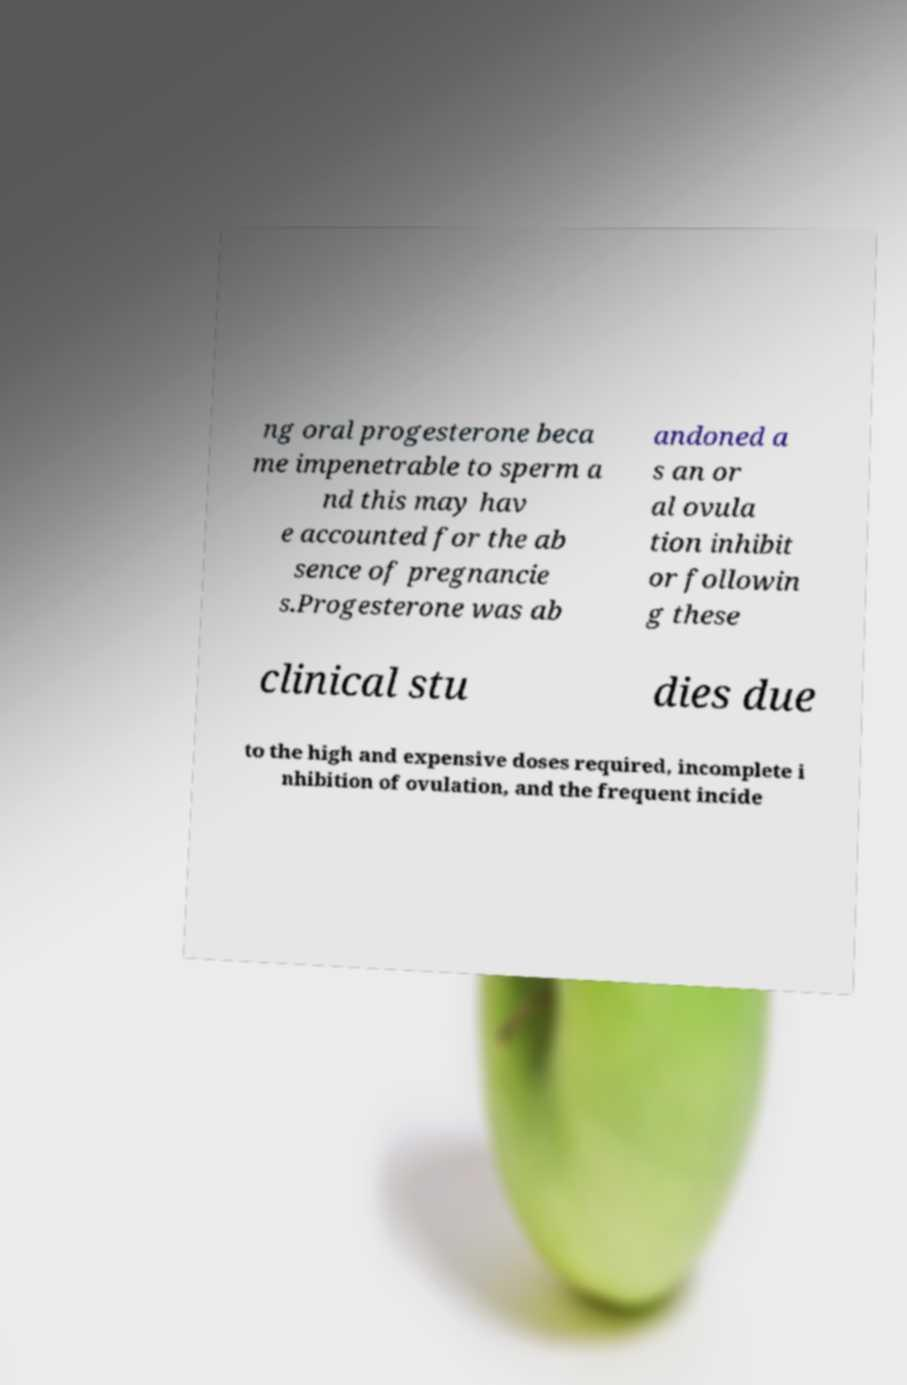Can you read and provide the text displayed in the image?This photo seems to have some interesting text. Can you extract and type it out for me? ng oral progesterone beca me impenetrable to sperm a nd this may hav e accounted for the ab sence of pregnancie s.Progesterone was ab andoned a s an or al ovula tion inhibit or followin g these clinical stu dies due to the high and expensive doses required, incomplete i nhibition of ovulation, and the frequent incide 